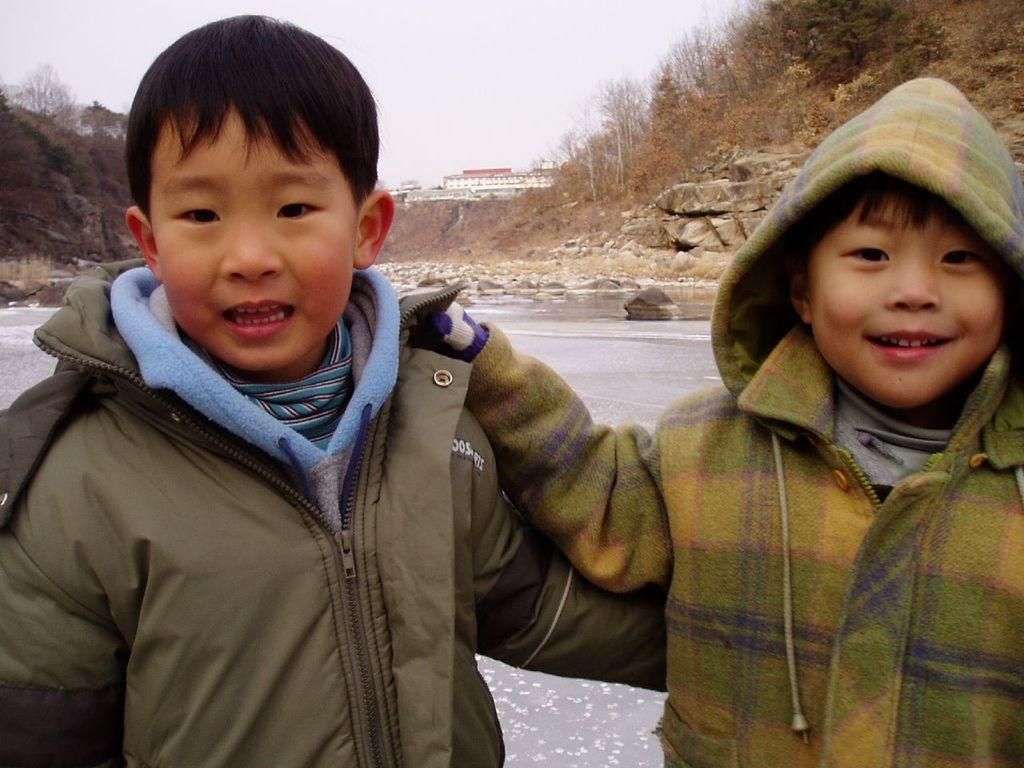What can be seen in the background of the image? The sky, buildings, rocks, and water are visible in the background of the image. What type of environment is depicted in the image? The image features a natural environment with water and rocks, as well as a man-made environment with buildings. What are the children wearing in the image? The children are wearing jackets in the image. What type of disease can be seen affecting the children in the image? There is no indication of any disease affecting the children in the image. What metal object can be seen in the image? There is no metal object present in the image. 